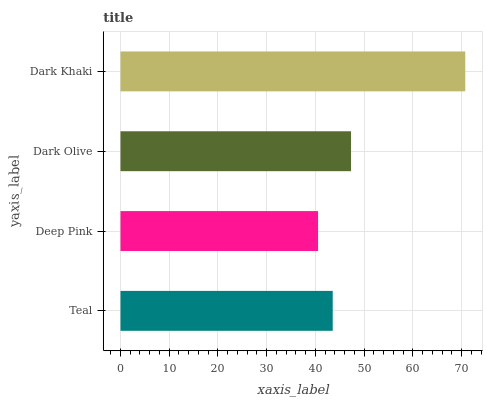Is Deep Pink the minimum?
Answer yes or no. Yes. Is Dark Khaki the maximum?
Answer yes or no. Yes. Is Dark Olive the minimum?
Answer yes or no. No. Is Dark Olive the maximum?
Answer yes or no. No. Is Dark Olive greater than Deep Pink?
Answer yes or no. Yes. Is Deep Pink less than Dark Olive?
Answer yes or no. Yes. Is Deep Pink greater than Dark Olive?
Answer yes or no. No. Is Dark Olive less than Deep Pink?
Answer yes or no. No. Is Dark Olive the high median?
Answer yes or no. Yes. Is Teal the low median?
Answer yes or no. Yes. Is Teal the high median?
Answer yes or no. No. Is Dark Khaki the low median?
Answer yes or no. No. 